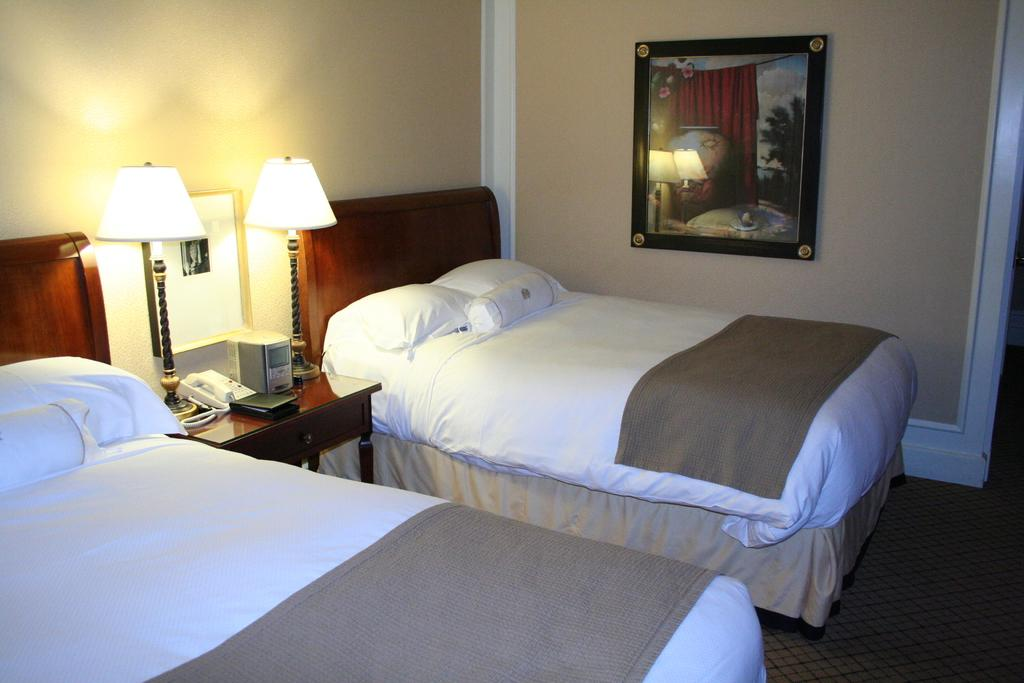How many beds are in the room in the image? There are two white beds in the image. Where are the beds located in the room? The beds are on either side of the room. What is in between the beds? There is a table in between the beds. What can be found on the table? The table has a telephone on it, and there are two lamps on the table. What type of nerve can be seen connecting the two beds in the image? There is no nerve connecting the two beds in the image; they are simply placed on either side of the room. 